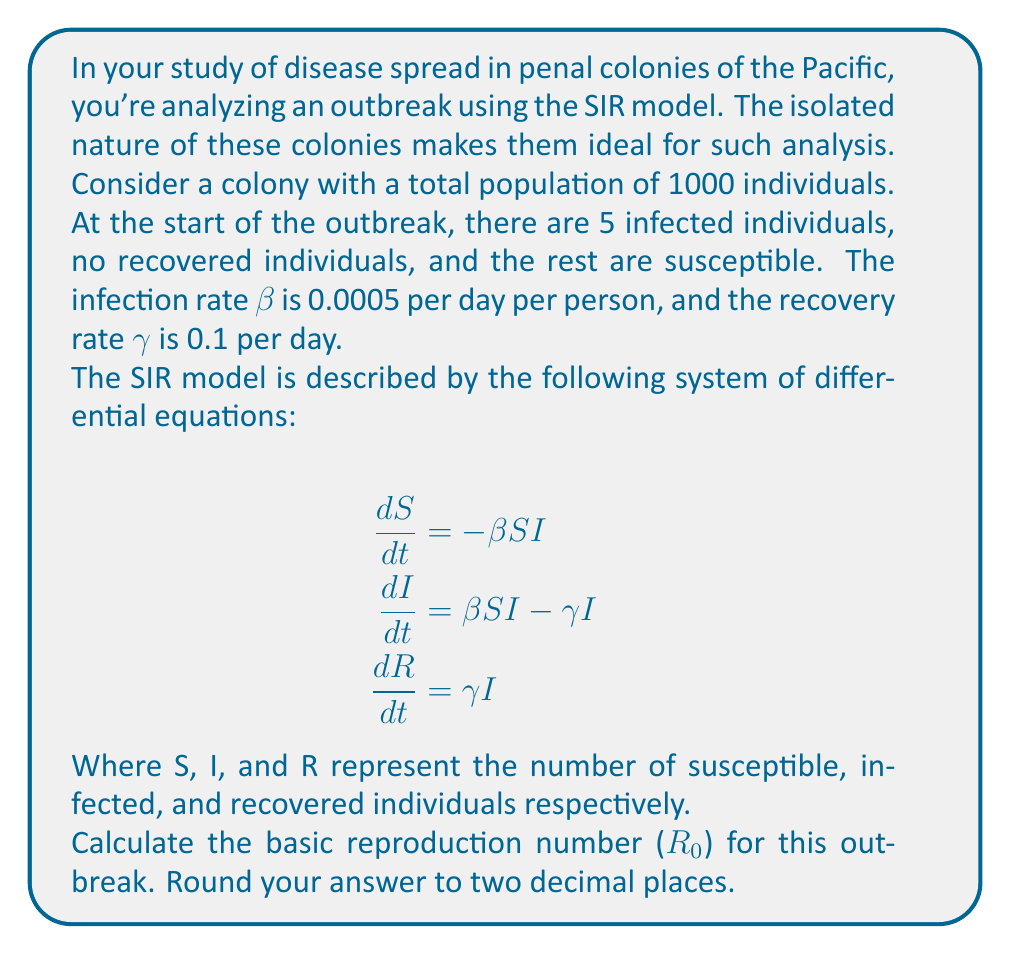Give your solution to this math problem. To solve this problem, we'll follow these steps:

1) Recall that the basic reproduction number (R₀) in the SIR model is given by:

   $$R_0 = \frac{\beta N}{\gamma}$$

   Where:
   - β is the infection rate
   - N is the total population
   - γ is the recovery rate

2) We're given:
   - β = 0.0005 per day per person
   - N = 1000 individuals
   - γ = 0.1 per day

3) Let's substitute these values into the formula:

   $$R_0 = \frac{0.0005 \times 1000}{0.1}$$

4) Simplify:
   
   $$R_0 = \frac{0.5}{0.1} = 5$$

5) The question asks for the answer rounded to two decimal places, but 5 is already in that form.

This R₀ value of 5 indicates that, on average, each infected person will infect 5 others in a fully susceptible population, suggesting a significant potential for the disease to spread in this isolated colony.
Answer: 5.00 